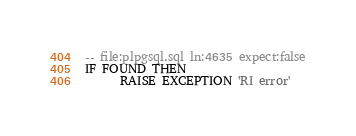<code> <loc_0><loc_0><loc_500><loc_500><_SQL_>-- file:plpgsql.sql ln:4635 expect:false
IF FOUND THEN
      RAISE EXCEPTION 'RI error'
</code> 